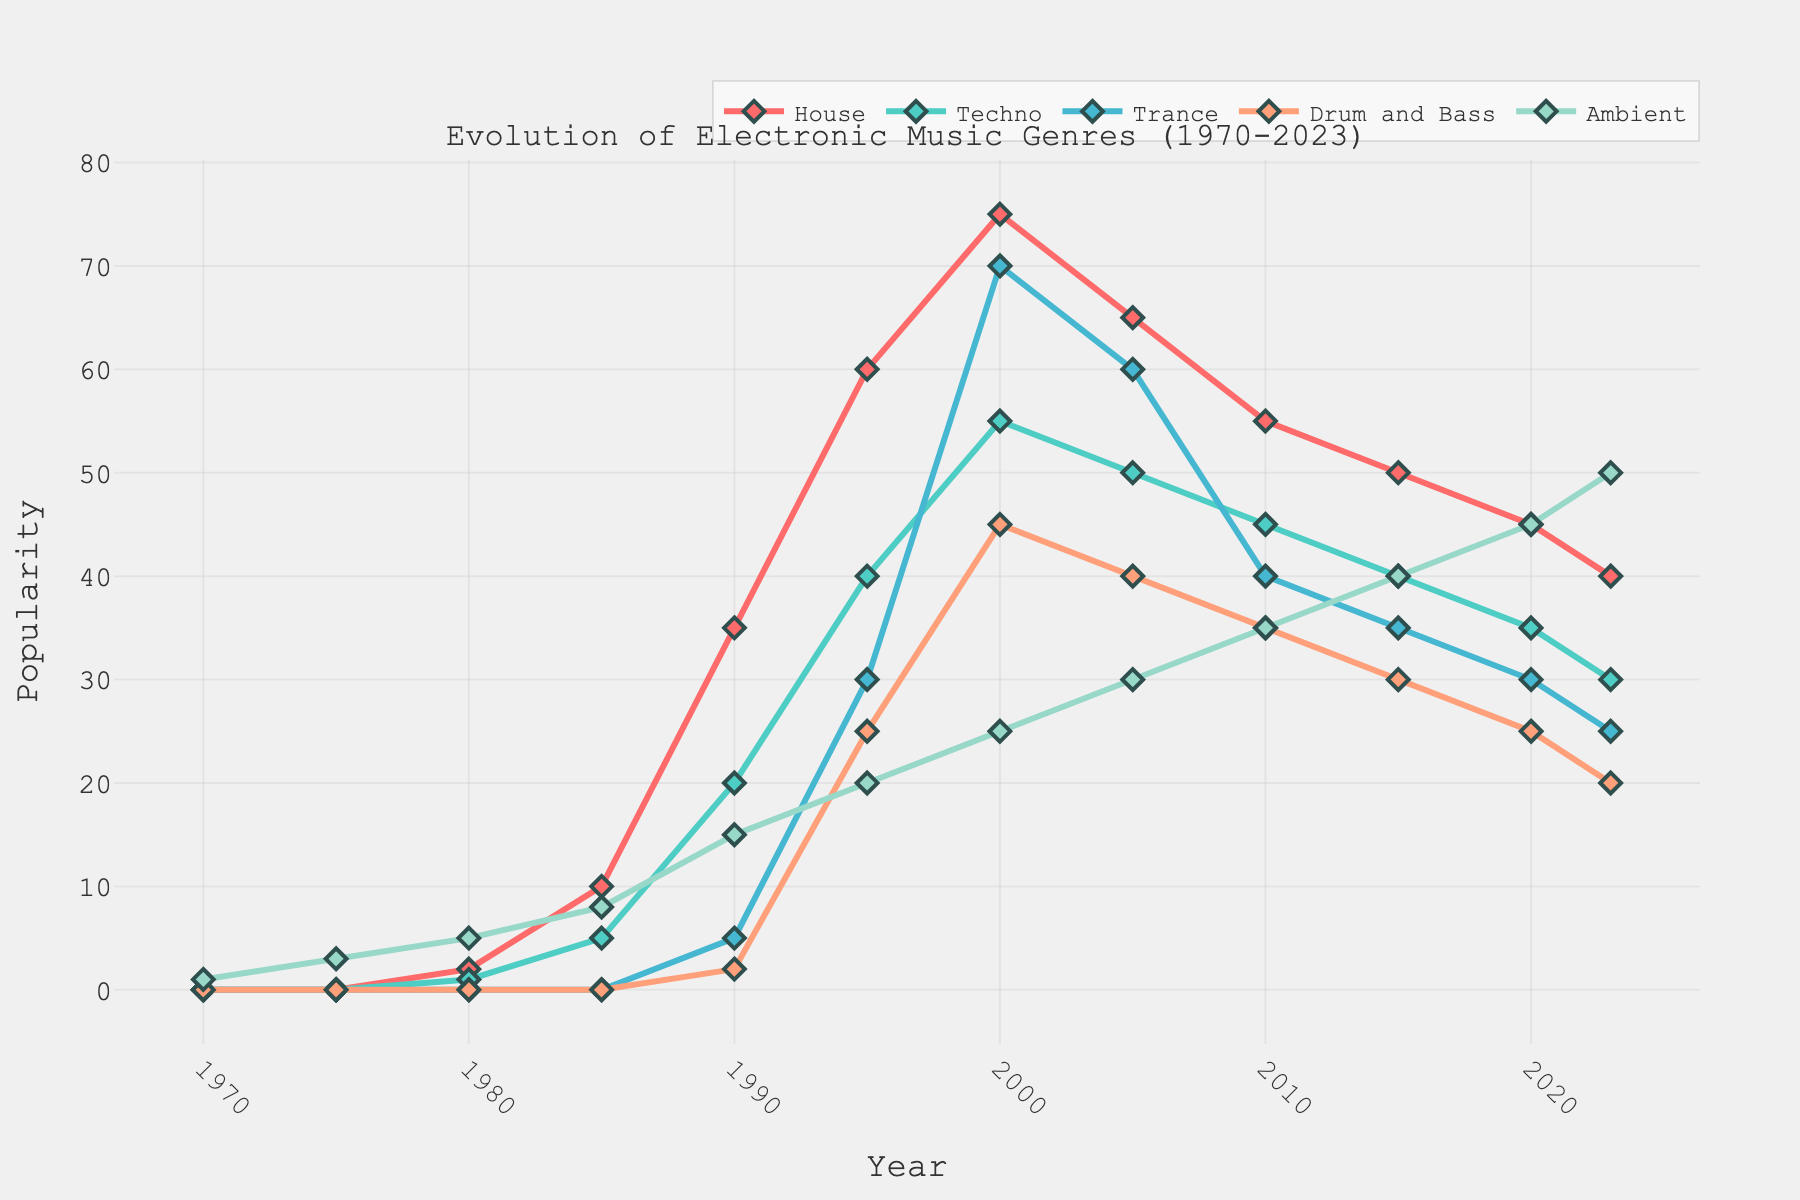Which genre was most popular in 1995? In 1995, the popularity values for each genre are: House (60), Techno (40), Trance (30), Drum and Bass (25), and Ambient (20). House has the highest value.
Answer: House What is the trend in popularity for Drum and Bass between 2000 and 2023? In 2000, Drum and Bass has a popularity of 45. By 2023, its popularity has decreased to 20. Thus, the trend for Drum and Bass shows a decline over these years.
Answer: Decline In which year did Techno peak in its popularity? Looking at the plot, Techno's popularity climbs until the year 2000, where it reaches its peak value of 55. After 2000, the values decrease.
Answer: 2000 Between 1985 and 1990, which genre showed the highest increase in popularity? From 1985 to 1990, the increases in popularity values for the genres are: House (25), Techno (15), Trance (5). Of these, House shows the highest increase.
Answer: House How does the popularity of Ambient in 2020 compare to 1980? In 2020, Ambient has a popularity of 45. In 1980, it has a popularity of 5. This indicates a significant increase over the years.
Answer: Significant increase What is the average popularity of House from 1970 to 2023? Sum up the popularity values of House from 1970 to 2023 and divide by the total number of years (12). Values: (0 + 0 + 2 + 10 + 35 + 60 + 75 + 65 + 55 + 50 + 45 + 40) = 437. Thus, 437 / 12 = 36.42
Answer: 36.42 Which genre experienced the most stable popularity trend? Observing the plotted lines, Ambient has a relatively steady increase in popularity without significant fluctuations compared to the other genres.
Answer: Ambient By how much did Trance's popularity decline from its peak in 2000 to 2023? Trance peaked at 70 in 2000 and dropped to 25 in 2023. Thus, the decline is 70 - 25 = 45.
Answer: 45 What is the combined popularity of Techno and Ambient in 2023? Techno has a popularity of 30 and Ambient has 50 in 2023. The combined popularity is 30 + 50 = 80.
Answer: 80 Compare the popularity of House and Ambient in 1980 and 2000. In 1980, House (2) and Ambient (5); Ambient is more popular. In 2000, House (75) and Ambient (25); House is more popular.
Answer: 1980: Ambient more popular; 2000: House more popular 